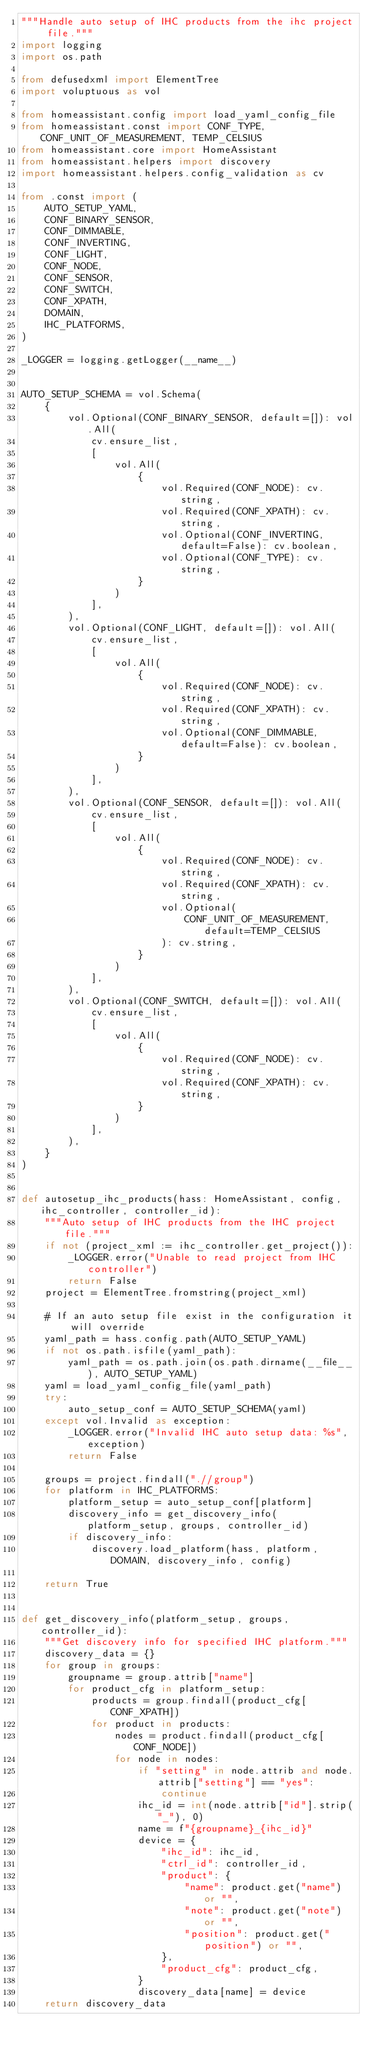Convert code to text. <code><loc_0><loc_0><loc_500><loc_500><_Python_>"""Handle auto setup of IHC products from the ihc project file."""
import logging
import os.path

from defusedxml import ElementTree
import voluptuous as vol

from homeassistant.config import load_yaml_config_file
from homeassistant.const import CONF_TYPE, CONF_UNIT_OF_MEASUREMENT, TEMP_CELSIUS
from homeassistant.core import HomeAssistant
from homeassistant.helpers import discovery
import homeassistant.helpers.config_validation as cv

from .const import (
    AUTO_SETUP_YAML,
    CONF_BINARY_SENSOR,
    CONF_DIMMABLE,
    CONF_INVERTING,
    CONF_LIGHT,
    CONF_NODE,
    CONF_SENSOR,
    CONF_SWITCH,
    CONF_XPATH,
    DOMAIN,
    IHC_PLATFORMS,
)

_LOGGER = logging.getLogger(__name__)


AUTO_SETUP_SCHEMA = vol.Schema(
    {
        vol.Optional(CONF_BINARY_SENSOR, default=[]): vol.All(
            cv.ensure_list,
            [
                vol.All(
                    {
                        vol.Required(CONF_NODE): cv.string,
                        vol.Required(CONF_XPATH): cv.string,
                        vol.Optional(CONF_INVERTING, default=False): cv.boolean,
                        vol.Optional(CONF_TYPE): cv.string,
                    }
                )
            ],
        ),
        vol.Optional(CONF_LIGHT, default=[]): vol.All(
            cv.ensure_list,
            [
                vol.All(
                    {
                        vol.Required(CONF_NODE): cv.string,
                        vol.Required(CONF_XPATH): cv.string,
                        vol.Optional(CONF_DIMMABLE, default=False): cv.boolean,
                    }
                )
            ],
        ),
        vol.Optional(CONF_SENSOR, default=[]): vol.All(
            cv.ensure_list,
            [
                vol.All(
                    {
                        vol.Required(CONF_NODE): cv.string,
                        vol.Required(CONF_XPATH): cv.string,
                        vol.Optional(
                            CONF_UNIT_OF_MEASUREMENT, default=TEMP_CELSIUS
                        ): cv.string,
                    }
                )
            ],
        ),
        vol.Optional(CONF_SWITCH, default=[]): vol.All(
            cv.ensure_list,
            [
                vol.All(
                    {
                        vol.Required(CONF_NODE): cv.string,
                        vol.Required(CONF_XPATH): cv.string,
                    }
                )
            ],
        ),
    }
)


def autosetup_ihc_products(hass: HomeAssistant, config, ihc_controller, controller_id):
    """Auto setup of IHC products from the IHC project file."""
    if not (project_xml := ihc_controller.get_project()):
        _LOGGER.error("Unable to read project from IHC controller")
        return False
    project = ElementTree.fromstring(project_xml)

    # If an auto setup file exist in the configuration it will override
    yaml_path = hass.config.path(AUTO_SETUP_YAML)
    if not os.path.isfile(yaml_path):
        yaml_path = os.path.join(os.path.dirname(__file__), AUTO_SETUP_YAML)
    yaml = load_yaml_config_file(yaml_path)
    try:
        auto_setup_conf = AUTO_SETUP_SCHEMA(yaml)
    except vol.Invalid as exception:
        _LOGGER.error("Invalid IHC auto setup data: %s", exception)
        return False

    groups = project.findall(".//group")
    for platform in IHC_PLATFORMS:
        platform_setup = auto_setup_conf[platform]
        discovery_info = get_discovery_info(platform_setup, groups, controller_id)
        if discovery_info:
            discovery.load_platform(hass, platform, DOMAIN, discovery_info, config)

    return True


def get_discovery_info(platform_setup, groups, controller_id):
    """Get discovery info for specified IHC platform."""
    discovery_data = {}
    for group in groups:
        groupname = group.attrib["name"]
        for product_cfg in platform_setup:
            products = group.findall(product_cfg[CONF_XPATH])
            for product in products:
                nodes = product.findall(product_cfg[CONF_NODE])
                for node in nodes:
                    if "setting" in node.attrib and node.attrib["setting"] == "yes":
                        continue
                    ihc_id = int(node.attrib["id"].strip("_"), 0)
                    name = f"{groupname}_{ihc_id}"
                    device = {
                        "ihc_id": ihc_id,
                        "ctrl_id": controller_id,
                        "product": {
                            "name": product.get("name") or "",
                            "note": product.get("note") or "",
                            "position": product.get("position") or "",
                        },
                        "product_cfg": product_cfg,
                    }
                    discovery_data[name] = device
    return discovery_data
</code> 